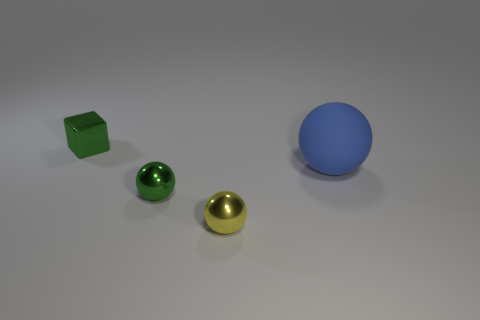If I were to roll one of these objects, which would travel the farthest? The blue sphere would likely roll the farthest due to its perfect round shape, which allows for minimal resistance and continuous motion, unlike the other shapes present.  What materials could these objects be made of, based on their appearance? Considering their lustrous finish and reflective qualities, the objects resemble materials like polished metal or glass. The blue sphere might be made of matte plastic or rubber based on its less reflective surface. 